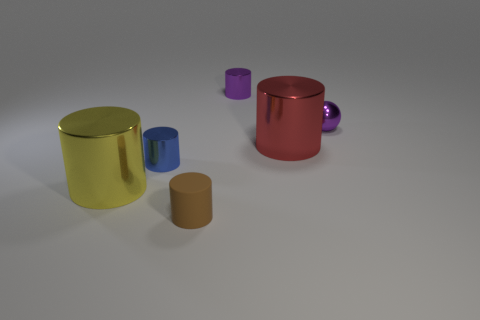What material is the big cylinder that is left of the small purple cylinder?
Make the answer very short. Metal. What number of shiny objects are either big green objects or tiny brown things?
Ensure brevity in your answer.  0. There is a big metal object in front of the cylinder to the right of the tiny purple metal cylinder; what color is it?
Offer a very short reply. Yellow. Does the tiny sphere have the same material as the tiny cylinder in front of the big yellow shiny object?
Offer a very short reply. No. There is a big cylinder right of the object in front of the big metallic cylinder in front of the red metallic cylinder; what is its color?
Give a very brief answer. Red. Is there any other thing that has the same shape as the small brown thing?
Your answer should be very brief. Yes. Are there more blue metal objects than green metal cubes?
Your response must be concise. Yes. How many small objects are both behind the small brown thing and left of the red metallic cylinder?
Give a very brief answer. 2. There is a thing on the right side of the large red object; what number of tiny purple objects are on the left side of it?
Provide a short and direct response. 1. Does the object to the right of the red object have the same size as the yellow metal cylinder behind the tiny brown matte cylinder?
Provide a short and direct response. No. 